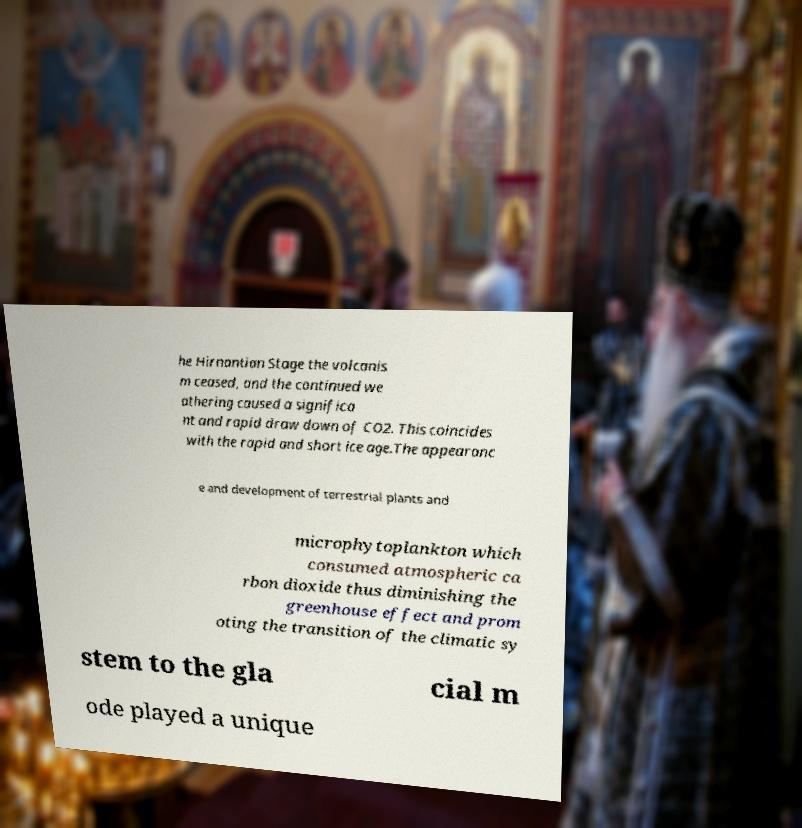Please identify and transcribe the text found in this image. he Hirnantian Stage the volcanis m ceased, and the continued we athering caused a significa nt and rapid draw down of CO2. This coincides with the rapid and short ice age.The appearanc e and development of terrestrial plants and microphytoplankton which consumed atmospheric ca rbon dioxide thus diminishing the greenhouse effect and prom oting the transition of the climatic sy stem to the gla cial m ode played a unique 